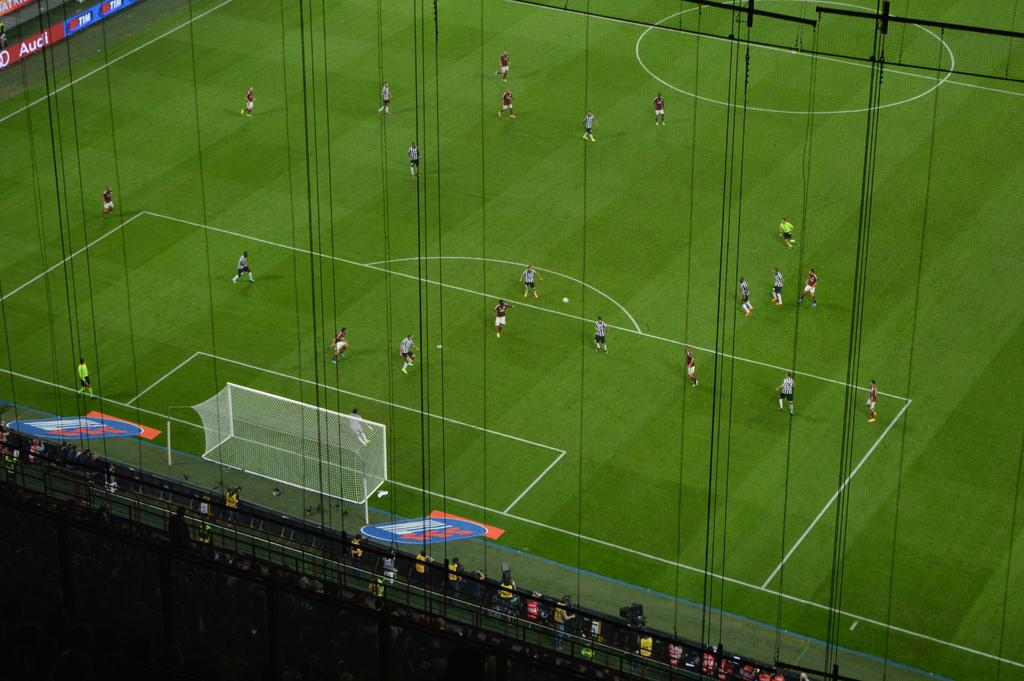What type of venue is depicted in the image? The image appears to be a football stadium. What activity is taking place on the ground? There are players on the ground, suggesting a football game is in progress. What is a key feature of a football field? There is a goal post visible in the image. Who is watching the game? There is an audience in the image. What additional information might be conveyed through the text on the boards? There are boards with text in the image, which could display team names, scores, or advertisements. Can you tell me how many grapes are on the field in the image? There are no grapes present in the image; it depicts a football game in a stadium. What type of medical professional is attending to the players in the image? There is no doctor present in the image; it focuses on the game and the audience. 